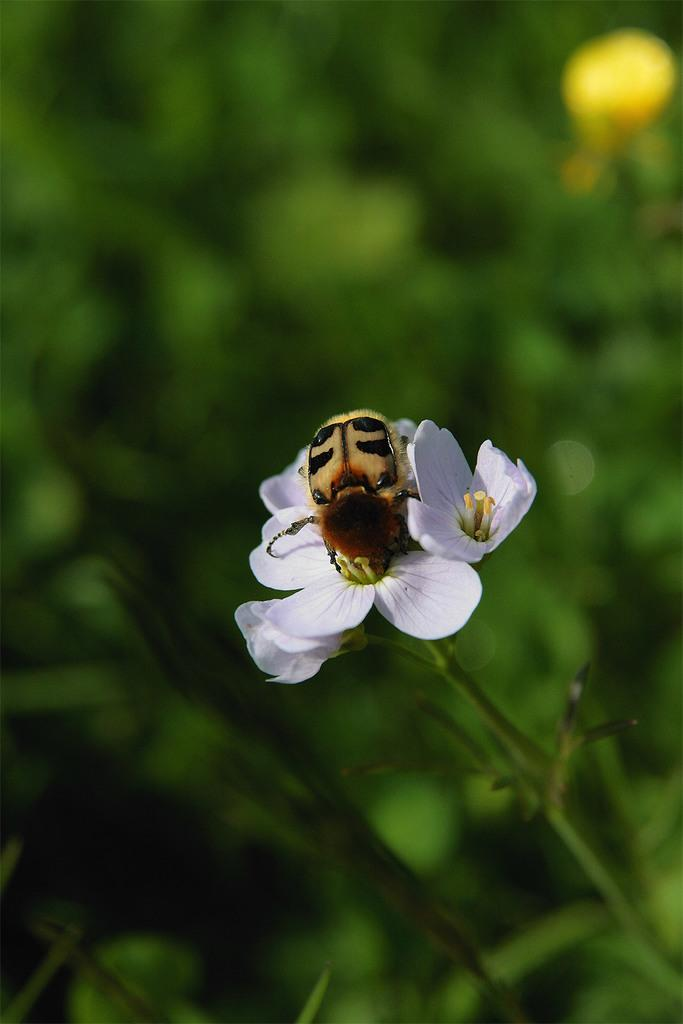What type of plant is visible in the image? There is a plant with flowers in the image. Can you describe any living organisms present on the plant? Yes, there is an insect on one of the flowers. What can be observed about the background of the image? The background of the image is blurred. What type of chance encounter might the insect have with a jewel in the image? There is no mention of a jewel in the image, so it is not possible to discuss any chance encounters between the insect and a jewel. 